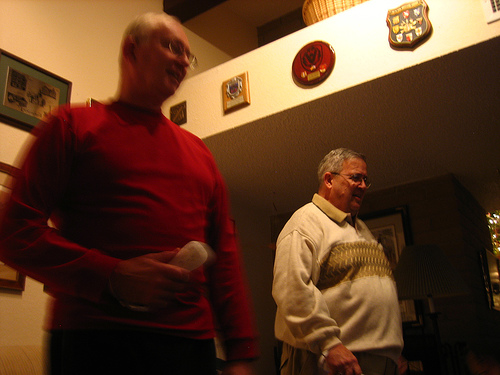Who is wearing the sweater? The man with the sweater is the one standing to the right in the image, wearing a cream-colored sweater adorned with a pattern. 